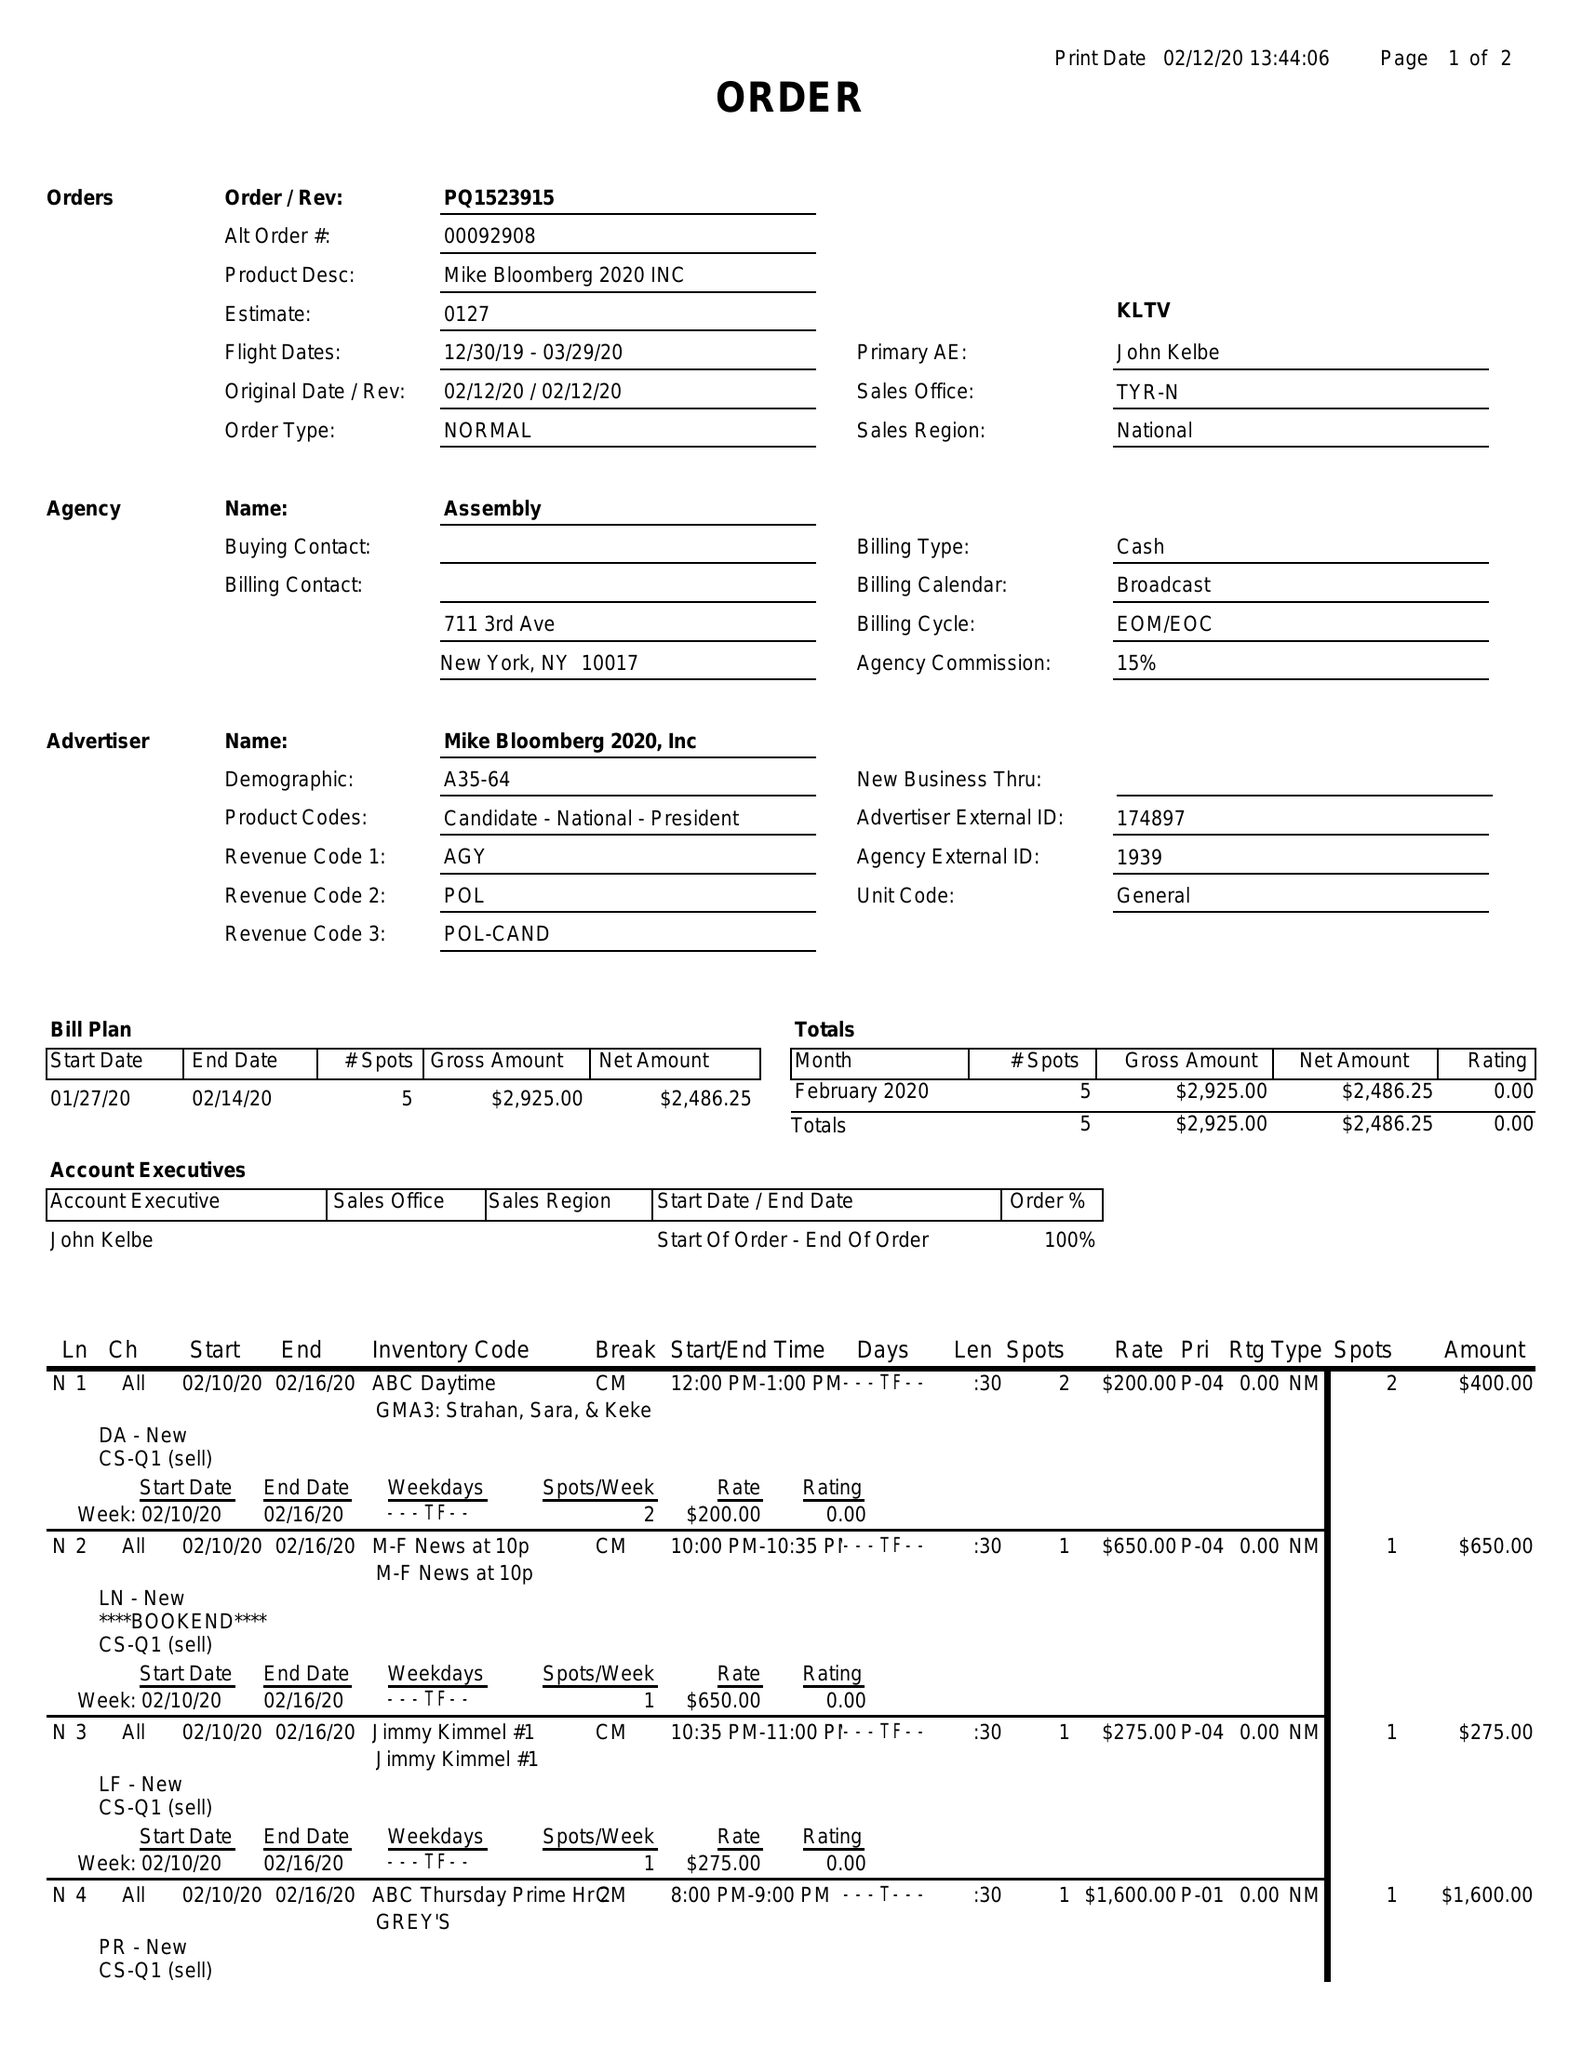What is the value for the gross_amount?
Answer the question using a single word or phrase. 2925.00 